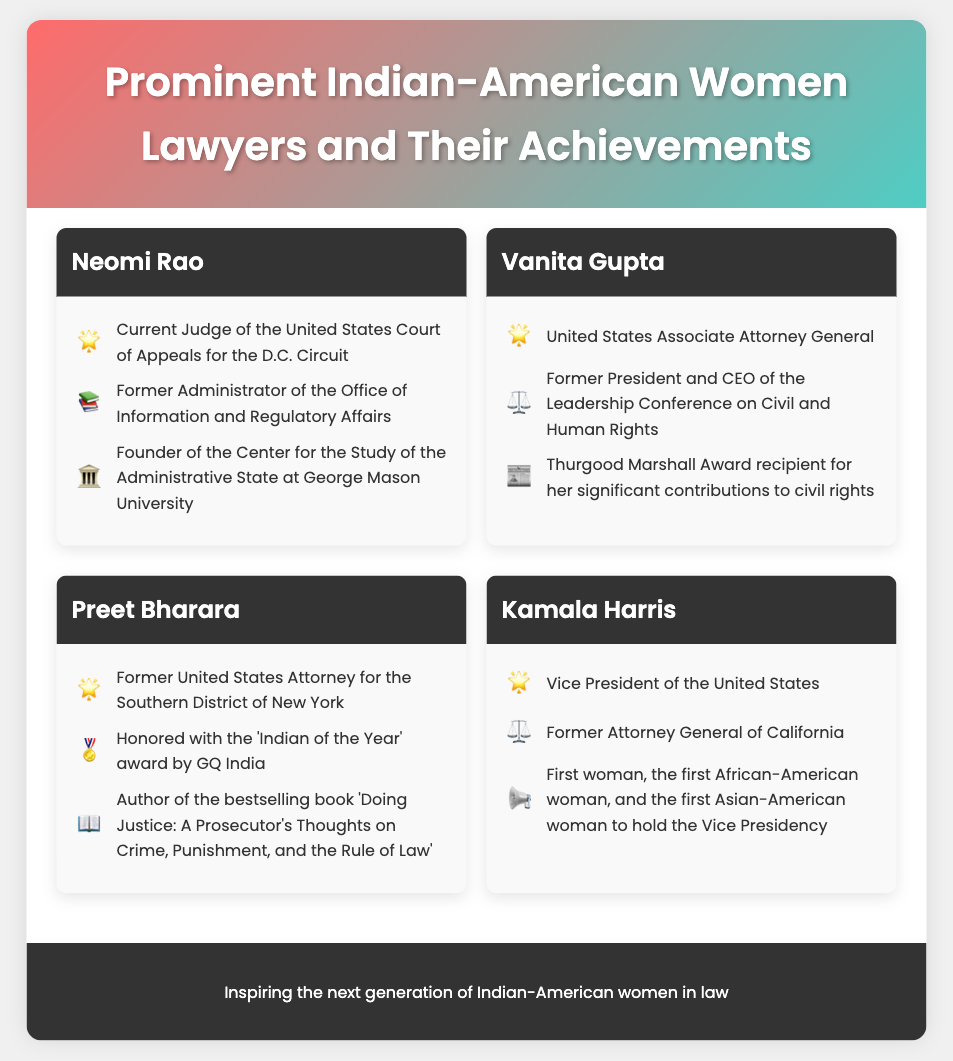What is Neomi Rao's current position? Neomi Rao is identified as a Judge of the United States Court of Appeals for the D.C. Circuit in the document.
Answer: Judge of the United States Court of Appeals for the D.C. Circuit Who is the United States Associate Attorney General? The document states that Vanita Gupta holds the position of United States Associate Attorney General.
Answer: Vanita Gupta Which award has Vanita Gupta received for her contributions to civil rights? The document indicates that Vanita Gupta is a Thurgood Marshall Award recipient.
Answer: Thurgood Marshall Award What unique distinction does Kamala Harris hold regarding her position as Vice President? The document notes that she is the first woman, the first African-American woman, and the first Asian-American woman to hold the Vice Presidency.
Answer: First woman, first African-American woman, first Asian-American woman How many key highlights are listed for Preet Bharara in the document? There are three key highlights listed for Preet Bharara according to the document.
Answer: Three What is the title of the bestselling book authored by Preet Bharara? The document mentions that the title of his bestselling book is 'Doing Justice: A Prosecutor's Thoughts on Crime, Punishment, and the Rule of Law'.
Answer: Doing Justice: A Prosecutor's Thoughts on Crime, Punishment, and the Rule of Law What institution did Neomi Rao found? The document highlights that she is the founder of the Center for the Study of the Administrative State at George Mason University.
Answer: Center for the Study of the Administrative State at George Mason University Who was the former President and CEO of the Leadership Conference on Civil and Human Rights? The document specifies that Vanita Gupta was the former President and CEO.
Answer: Vanita Gupta What career symbol is used to highlight Kamala Harris's position? The document uses the symbol ⚖️ next to the description of Kamala Harris's career highlights.
Answer: ⚖️ 